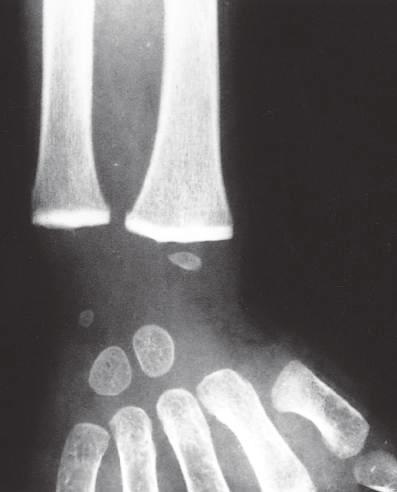has impaired remodeling of calcified cartilage in the epiphyses of the wrist caused a marked increase in their radiodensity, so that they are as radiopaque as the cortical bone?
Answer the question using a single word or phrase. Yes 